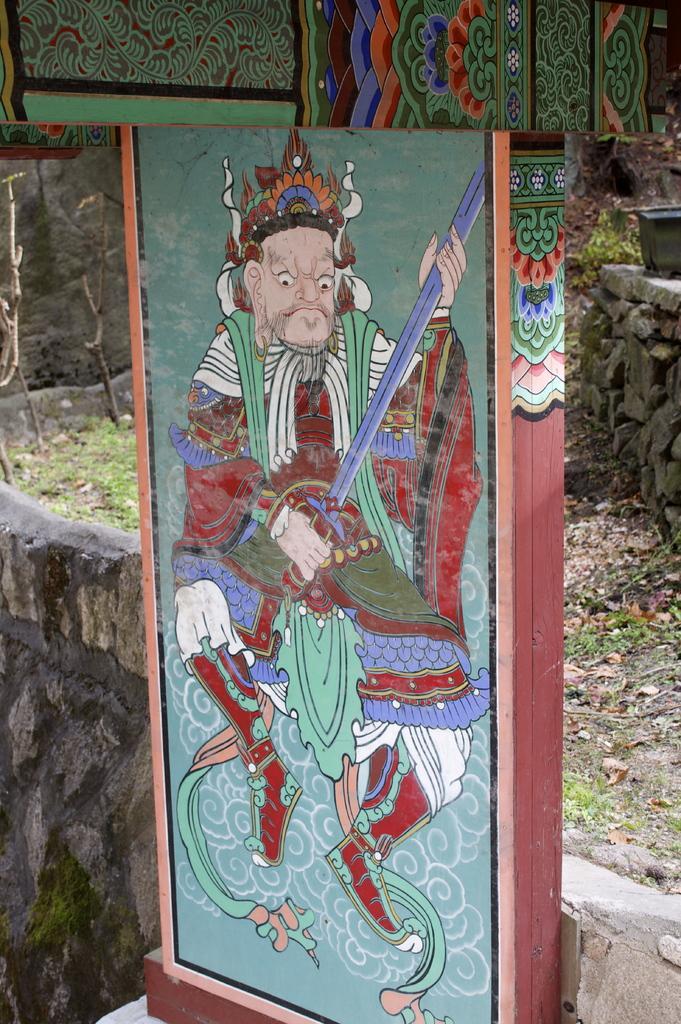Can you describe this image briefly? In this image there is a painting on a wooden board, behind the board there are rocks and there are some dry leaves on the surface. 